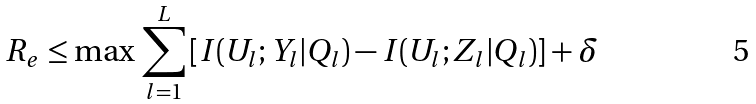Convert formula to latex. <formula><loc_0><loc_0><loc_500><loc_500>R _ { e } \leq \max \, \sum _ { l = 1 } ^ { L } \left [ I ( U _ { l } ; Y _ { l } | Q _ { l } ) - I ( U _ { l } ; Z _ { l } | Q _ { l } ) \right ] + \delta</formula> 